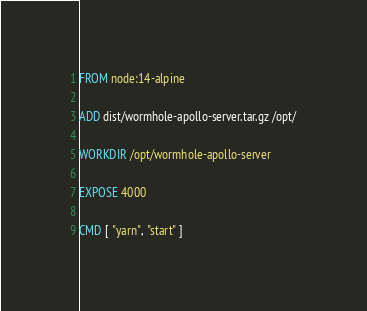Convert code to text. <code><loc_0><loc_0><loc_500><loc_500><_Dockerfile_>FROM node:14-alpine

ADD dist/wormhole-apollo-server.tar.gz /opt/

WORKDIR /opt/wormhole-apollo-server

EXPOSE 4000

CMD [ "yarn", "start" ]
</code> 